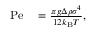<formula> <loc_0><loc_0><loc_500><loc_500>\begin{array} { r l } { P e } & = \frac { \pi g \Delta \rho \sigma ^ { 4 } } { 1 2 k _ { B } T } , } \end{array}</formula> 